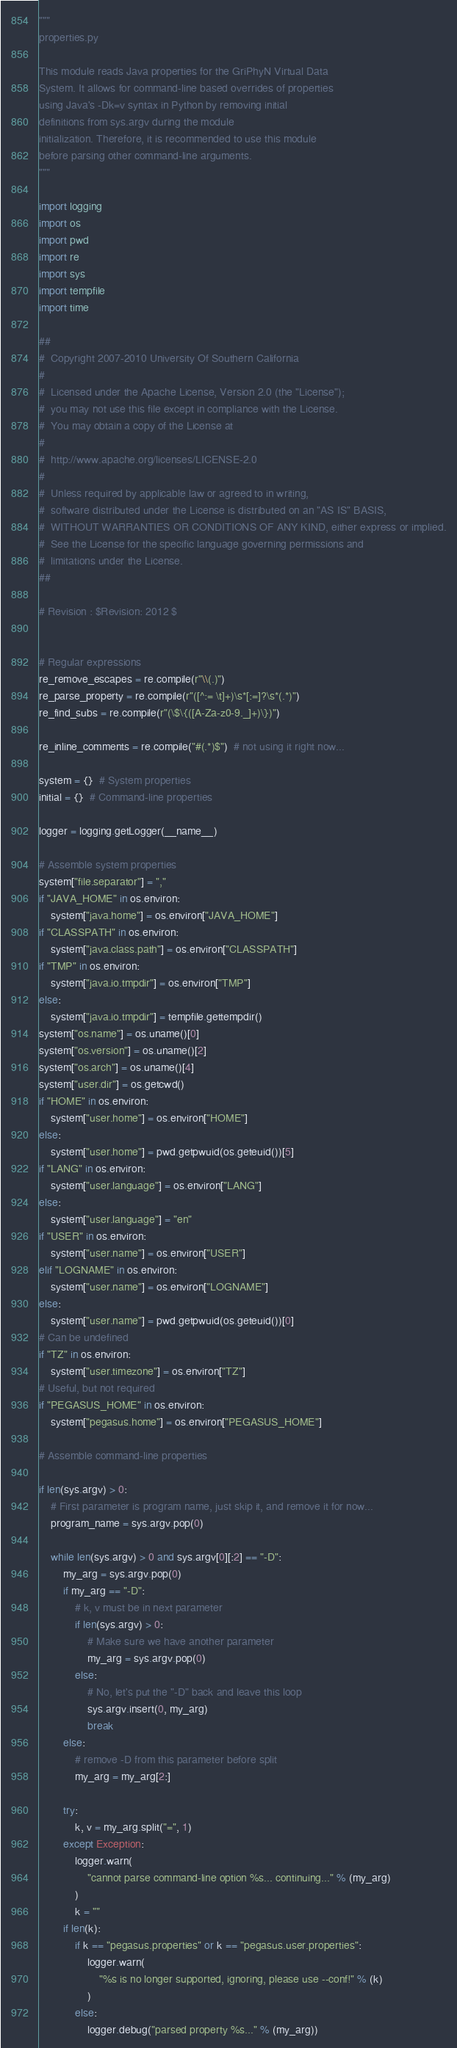<code> <loc_0><loc_0><loc_500><loc_500><_Python_>"""
properties.py

This module reads Java properties for the GriPhyN Virtual Data
System. It allows for command-line based overrides of properties
using Java's -Dk=v syntax in Python by removing initial
definitions from sys.argv during the module
initialization. Therefore, it is recommended to use this module
before parsing other command-line arguments.
"""

import logging
import os
import pwd
import re
import sys
import tempfile
import time

##
#  Copyright 2007-2010 University Of Southern California
#
#  Licensed under the Apache License, Version 2.0 (the "License");
#  you may not use this file except in compliance with the License.
#  You may obtain a copy of the License at
#
#  http://www.apache.org/licenses/LICENSE-2.0
#
#  Unless required by applicable law or agreed to in writing,
#  software distributed under the License is distributed on an "AS IS" BASIS,
#  WITHOUT WARRANTIES OR CONDITIONS OF ANY KIND, either express or implied.
#  See the License for the specific language governing permissions and
#  limitations under the License.
##

# Revision : $Revision: 2012 $


# Regular expressions
re_remove_escapes = re.compile(r"\\(.)")
re_parse_property = re.compile(r"([^:= \t]+)\s*[:=]?\s*(.*)")
re_find_subs = re.compile(r"(\$\{([A-Za-z0-9._]+)\})")

re_inline_comments = re.compile("#(.*)$")  # not using it right now...

system = {}  # System properties
initial = {}  # Command-line properties

logger = logging.getLogger(__name__)

# Assemble system properties
system["file.separator"] = ","
if "JAVA_HOME" in os.environ:
    system["java.home"] = os.environ["JAVA_HOME"]
if "CLASSPATH" in os.environ:
    system["java.class.path"] = os.environ["CLASSPATH"]
if "TMP" in os.environ:
    system["java.io.tmpdir"] = os.environ["TMP"]
else:
    system["java.io.tmpdir"] = tempfile.gettempdir()
system["os.name"] = os.uname()[0]
system["os.version"] = os.uname()[2]
system["os.arch"] = os.uname()[4]
system["user.dir"] = os.getcwd()
if "HOME" in os.environ:
    system["user.home"] = os.environ["HOME"]
else:
    system["user.home"] = pwd.getpwuid(os.geteuid())[5]
if "LANG" in os.environ:
    system["user.language"] = os.environ["LANG"]
else:
    system["user.language"] = "en"
if "USER" in os.environ:
    system["user.name"] = os.environ["USER"]
elif "LOGNAME" in os.environ:
    system["user.name"] = os.environ["LOGNAME"]
else:
    system["user.name"] = pwd.getpwuid(os.geteuid())[0]
# Can be undefined
if "TZ" in os.environ:
    system["user.timezone"] = os.environ["TZ"]
# Useful, but not required
if "PEGASUS_HOME" in os.environ:
    system["pegasus.home"] = os.environ["PEGASUS_HOME"]

# Assemble command-line properties

if len(sys.argv) > 0:
    # First parameter is program name, just skip it, and remove it for now...
    program_name = sys.argv.pop(0)

    while len(sys.argv) > 0 and sys.argv[0][:2] == "-D":
        my_arg = sys.argv.pop(0)
        if my_arg == "-D":
            # k, v must be in next parameter
            if len(sys.argv) > 0:
                # Make sure we have another parameter
                my_arg = sys.argv.pop(0)
            else:
                # No, let's put the "-D" back and leave this loop
                sys.argv.insert(0, my_arg)
                break
        else:
            # remove -D from this parameter before split
            my_arg = my_arg[2:]

        try:
            k, v = my_arg.split("=", 1)
        except Exception:
            logger.warn(
                "cannot parse command-line option %s... continuing..." % (my_arg)
            )
            k = ""
        if len(k):
            if k == "pegasus.properties" or k == "pegasus.user.properties":
                logger.warn(
                    "%s is no longer supported, ignoring, please use --conf!" % (k)
                )
            else:
                logger.debug("parsed property %s..." % (my_arg))</code> 